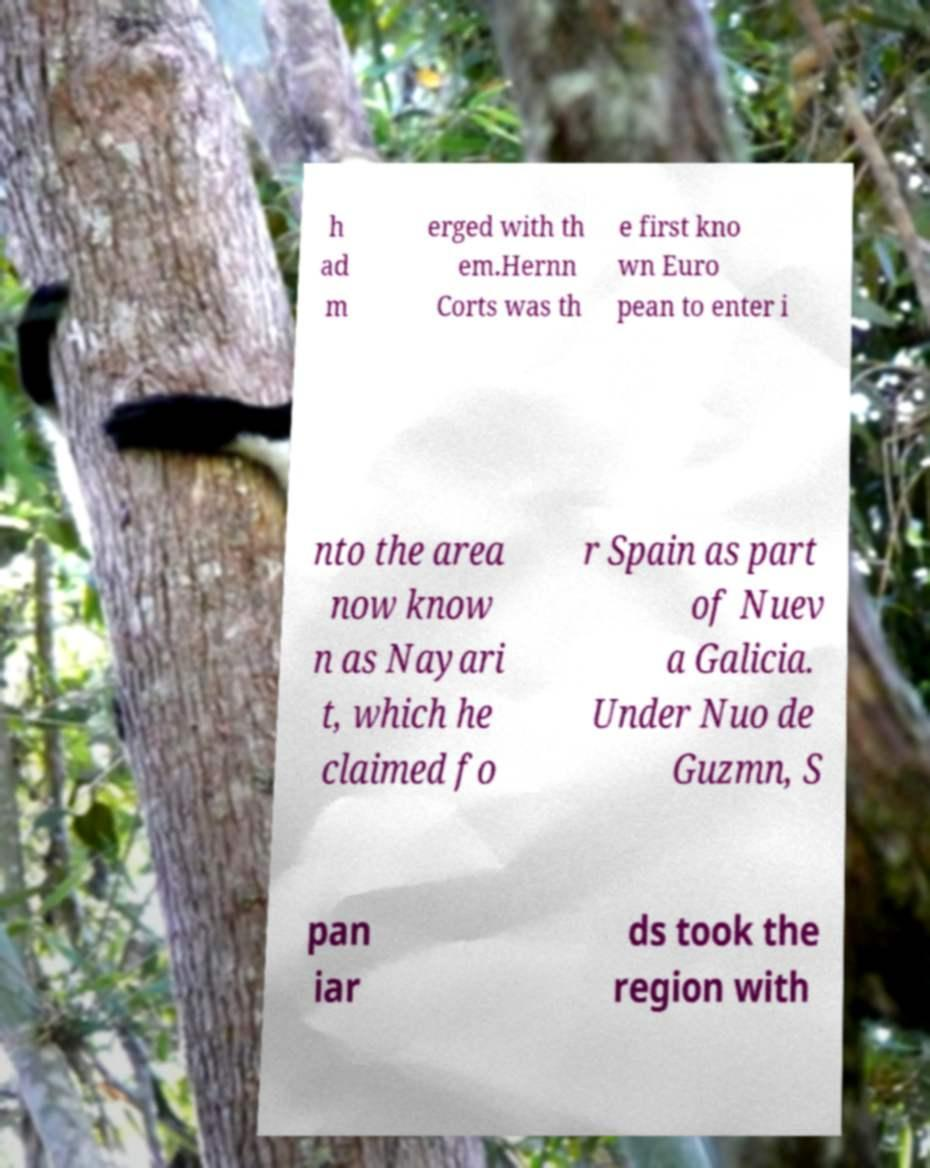Can you read and provide the text displayed in the image?This photo seems to have some interesting text. Can you extract and type it out for me? h ad m erged with th em.Hernn Corts was th e first kno wn Euro pean to enter i nto the area now know n as Nayari t, which he claimed fo r Spain as part of Nuev a Galicia. Under Nuo de Guzmn, S pan iar ds took the region with 